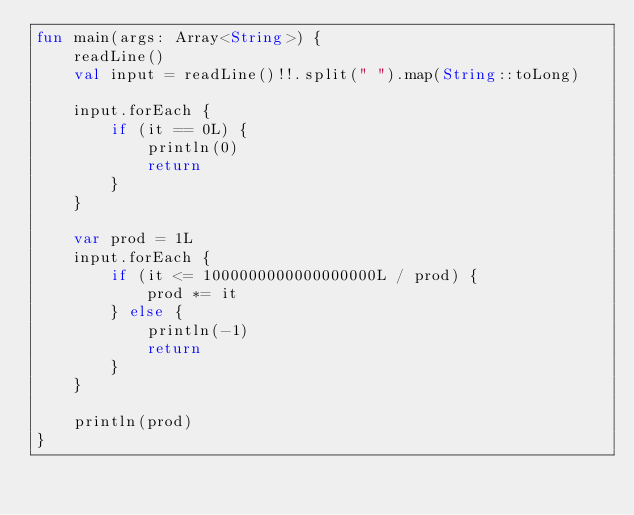<code> <loc_0><loc_0><loc_500><loc_500><_Kotlin_>fun main(args: Array<String>) {
    readLine()
    val input = readLine()!!.split(" ").map(String::toLong)

    input.forEach {
        if (it == 0L) {
            println(0)
            return
        }
    }

    var prod = 1L
    input.forEach {
        if (it <= 1000000000000000000L / prod) {
            prod *= it
        } else {
            println(-1)
            return
        }
    }

    println(prod)
}
</code> 